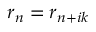<formula> <loc_0><loc_0><loc_500><loc_500>r _ { n } = r _ { n + i k }</formula> 